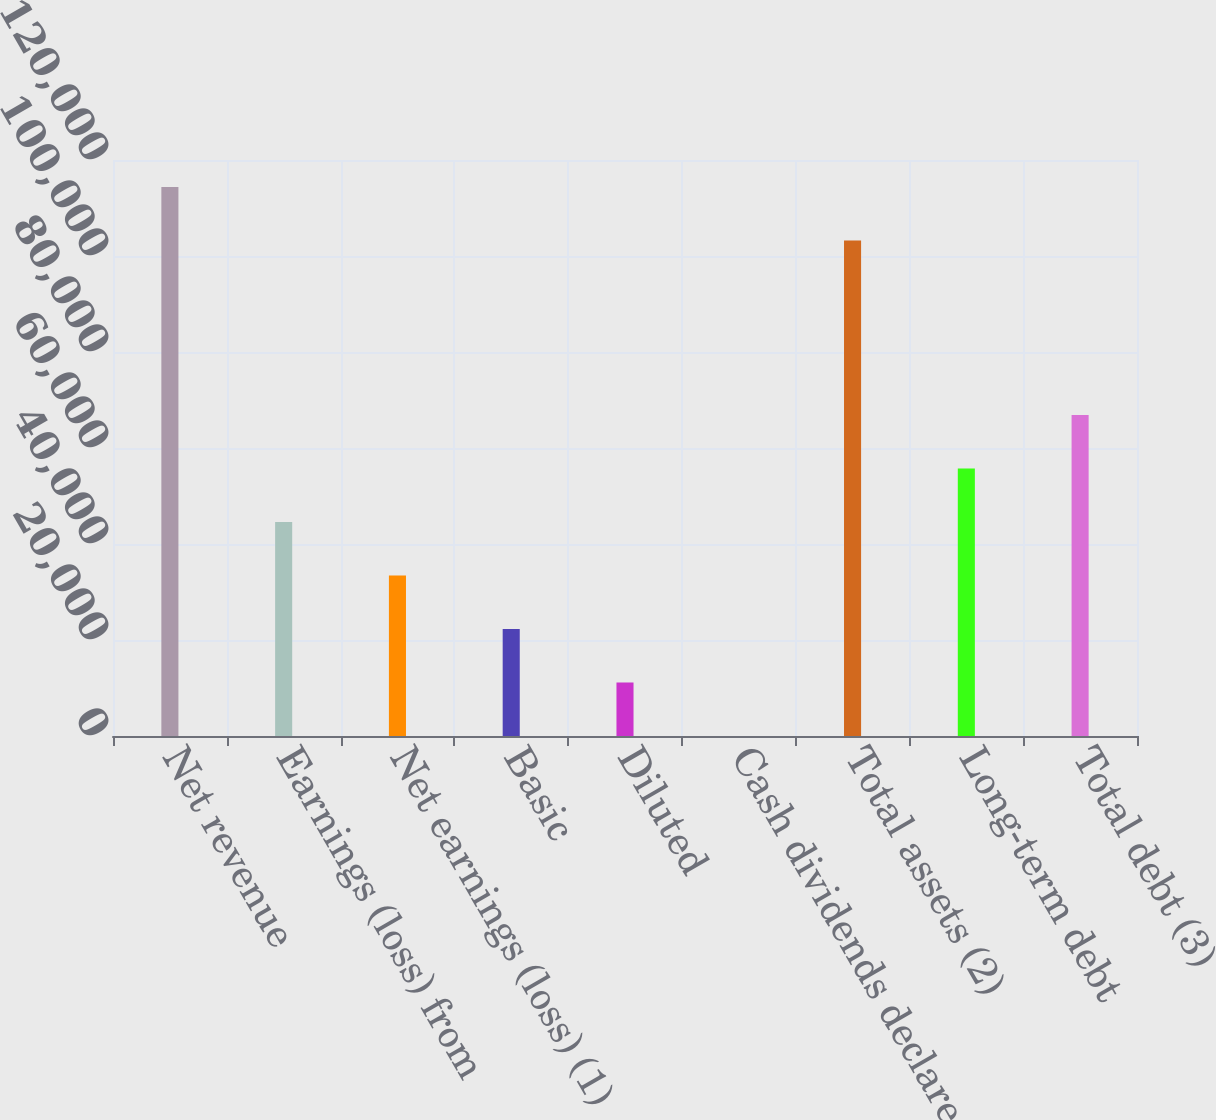Convert chart to OTSL. <chart><loc_0><loc_0><loc_500><loc_500><bar_chart><fcel>Net revenue<fcel>Earnings (loss) from<fcel>Net earnings (loss) (1)<fcel>Basic<fcel>Diluted<fcel>Cash dividends declared per<fcel>Total assets (2)<fcel>Long-term debt<fcel>Total debt (3)<nl><fcel>114351<fcel>44582<fcel>33436.6<fcel>22291.3<fcel>11146<fcel>0.61<fcel>103206<fcel>55727.3<fcel>66872.6<nl></chart> 